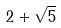Convert formula to latex. <formula><loc_0><loc_0><loc_500><loc_500>2 + \sqrt { 5 }</formula> 